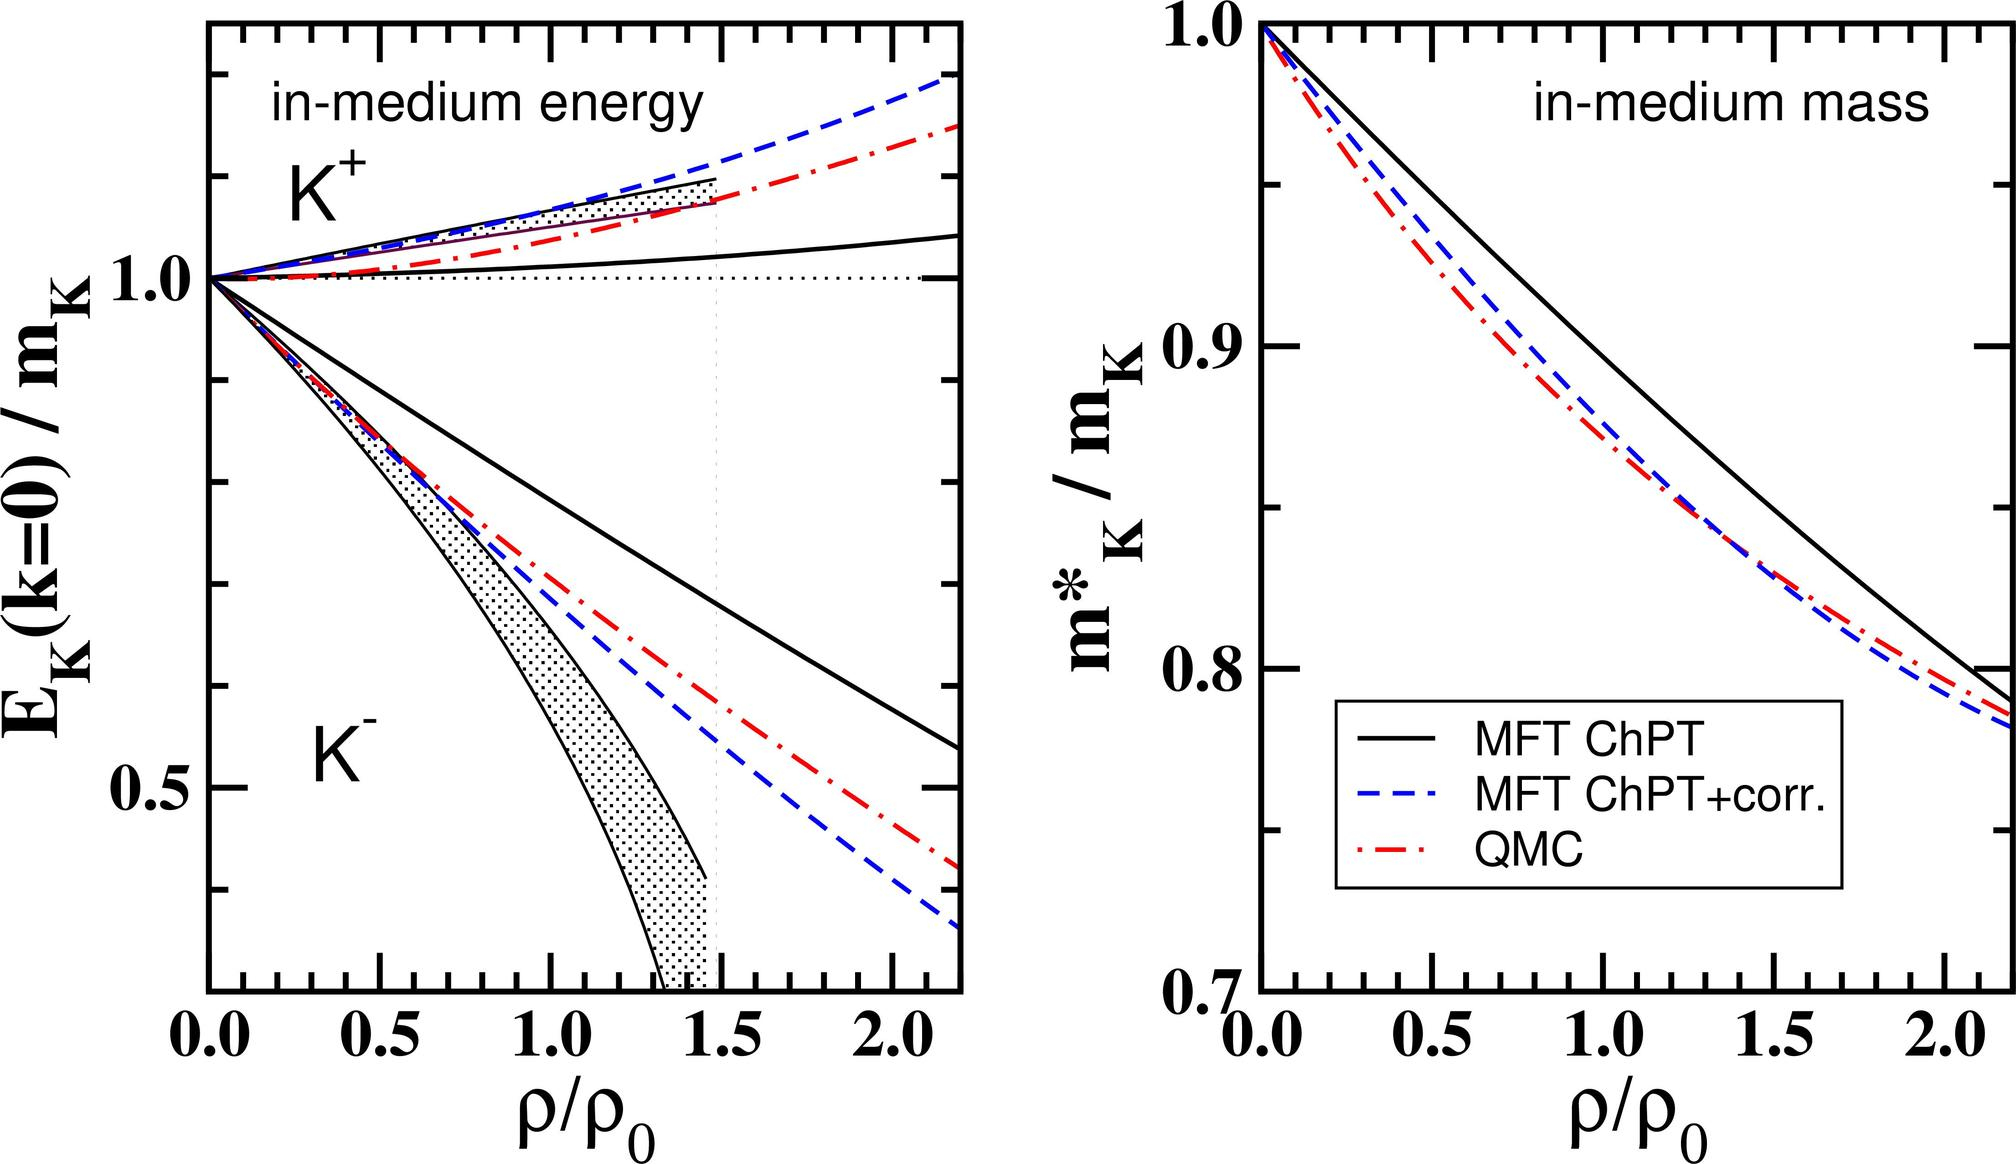Which model, according to the right graph, predicts the smallest decrease in the \( K^+ \) meson mass in the medium at twice the standard nuclear density (\( 2\rho_0 \))? A. Mean Field Theory (MFT) Chiral Perturbation Theory (ChPT) B. MFT ChPT with corrections (corr.) C. Quark-Meson Coupling (QMC) D. The models predict the same decrease in \( K^+ \) meson mass at \( 2\rho_0 \). At \( \rho/\rho_0 = 2 \), the solid line representing MFT ChPT lies highest on the graph, indicating it predicts the least decrease in the in-medium mass of \( K^+ \) mesons compared to the dashed lines representing the other models. Therefore, the correct answer is A. 